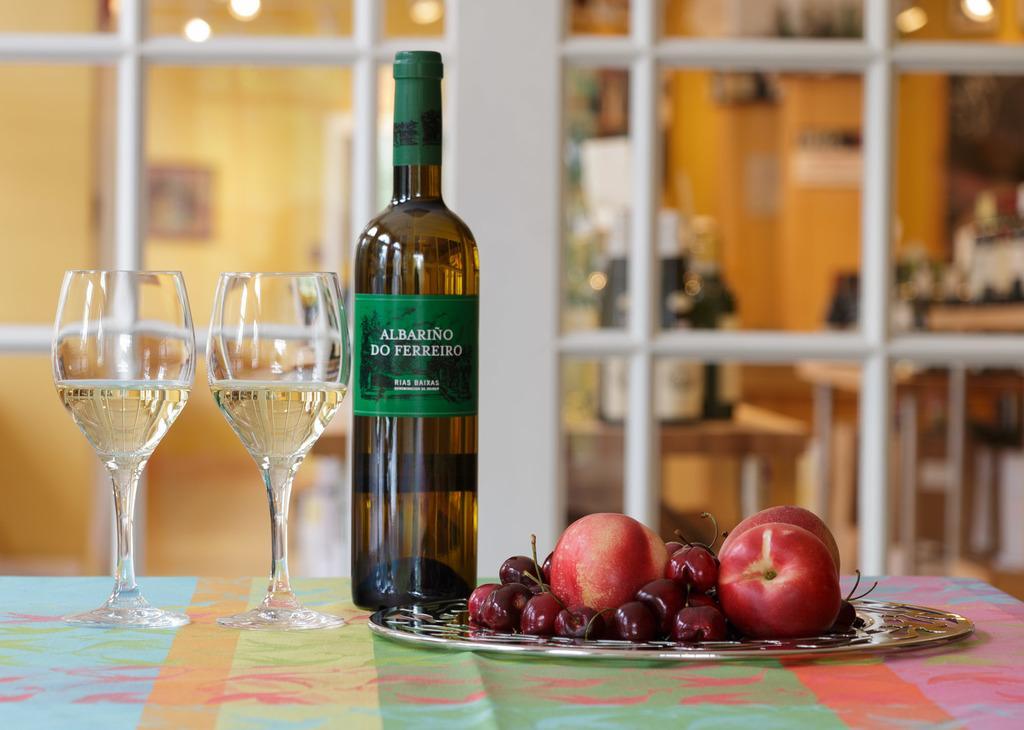Can you describe this image briefly? In this picture we can see couple of glasses, bottle and fruits on the table, in the background we can see couple of bottles on the table and a wall. 